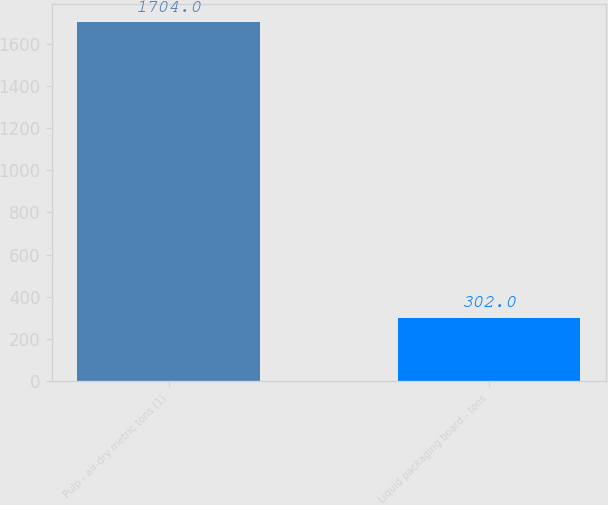Convert chart to OTSL. <chart><loc_0><loc_0><loc_500><loc_500><bar_chart><fcel>Pulp - air-dry metric tons (1)<fcel>Liquid packaging board - tons<nl><fcel>1704<fcel>302<nl></chart> 